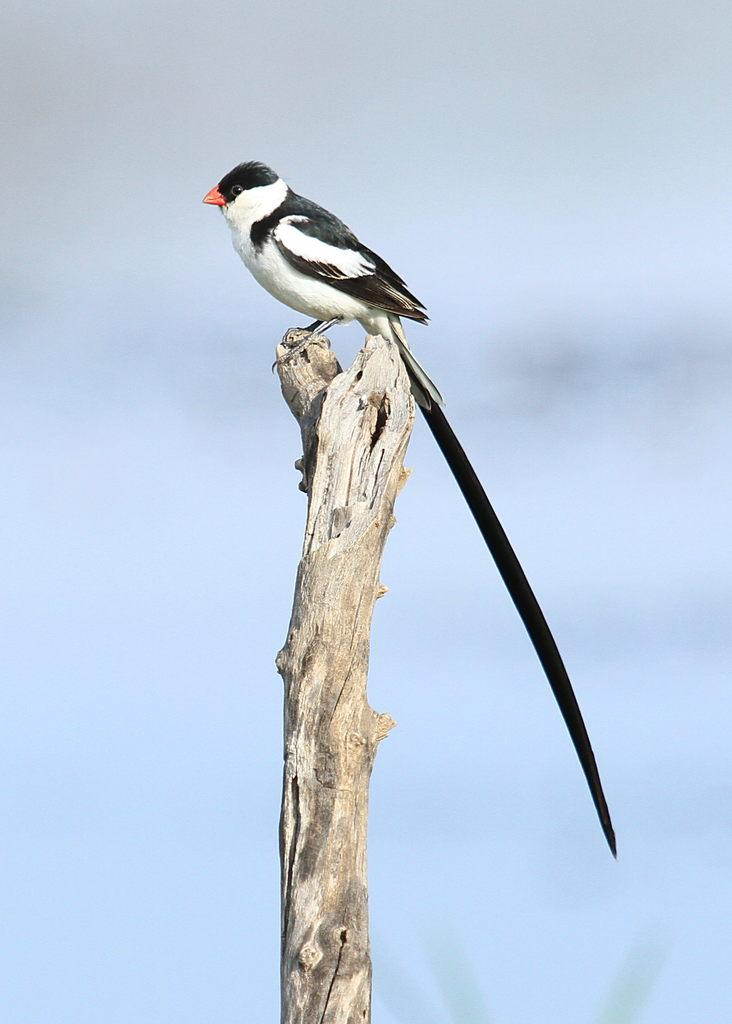What type of animal can be seen in the image? There is a bird in the image. How is the bird positioned in the image? The bird is on a stick. In which direction is the bird looking? The bird is looking towards the left side. What is a distinctive feature of the bird? The bird has a long tail. What can be seen at the top of the image? The sky is visible at the top of the image. What type of clam is being cooked in the tin in the image? There is no clam or tin present in the image; it features a bird on a stick. Is the bird feeling hot in the image? The image does not provide information about the bird's temperature, so it cannot be determined if the bird is feeling hot. 